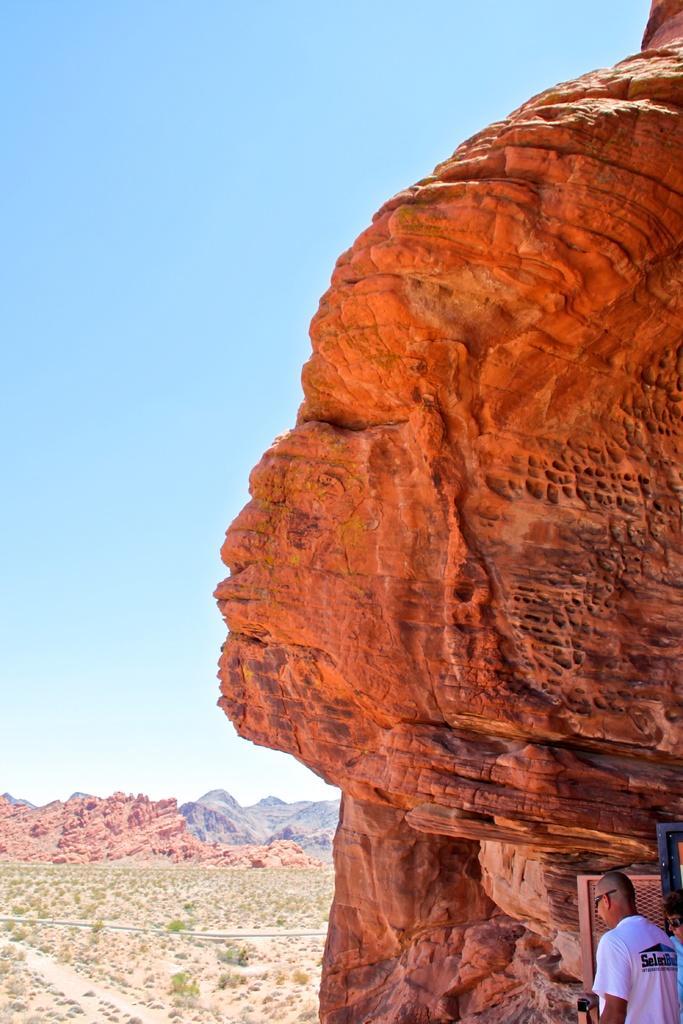Describe this image in one or two sentences. In this picture there is a sculpture on the right side of the image and there is a man in the bottom right side of the image and there are rocks on the left side of the image. 